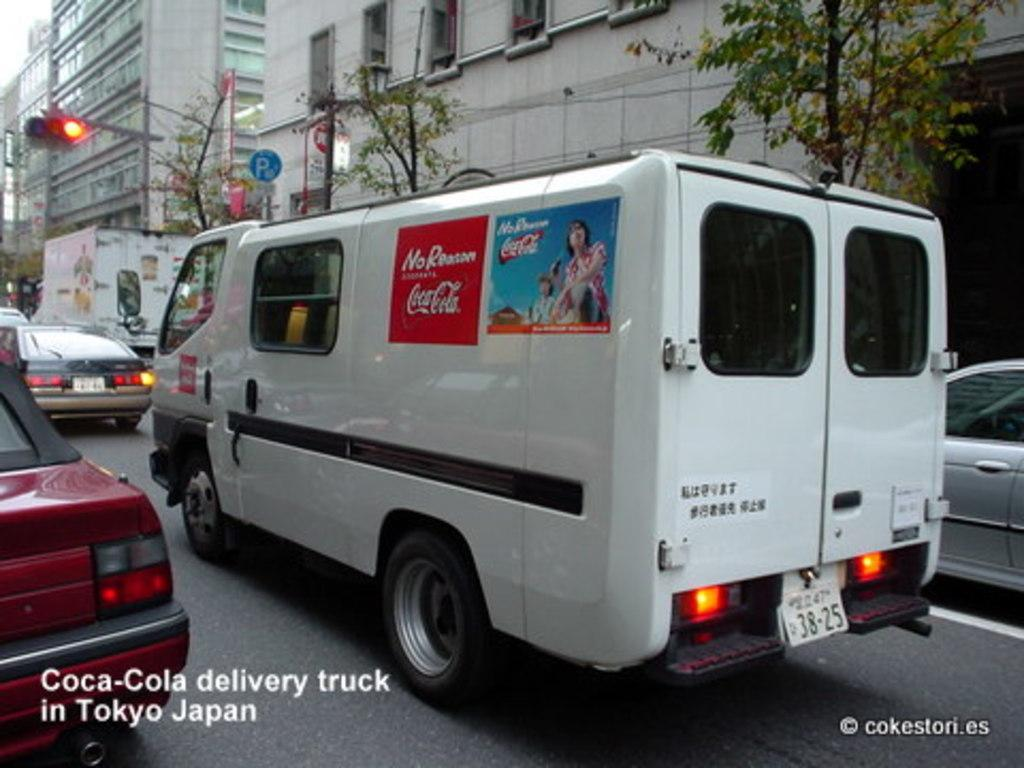Provide a one-sentence caption for the provided image. A van is branded with two Coca-Cola advertisements. 